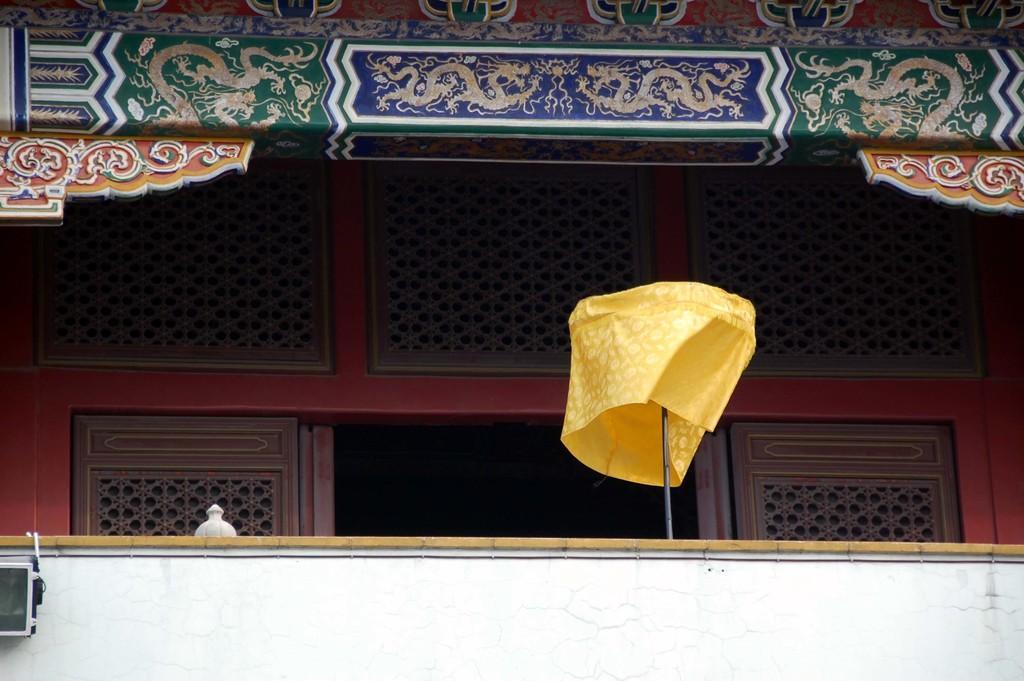In one or two sentences, can you explain what this image depicts? This is a building. At the bottom there is a wall. In the background there is another wall made up of wood. At the top, I can see few colorful paintings on the wall. 